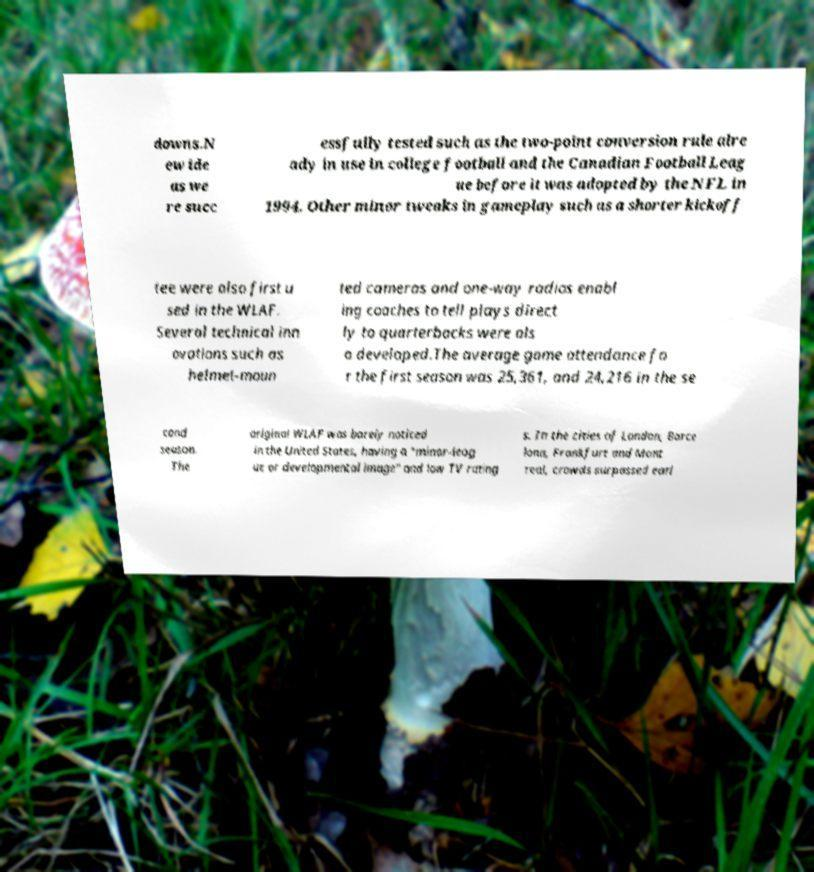For documentation purposes, I need the text within this image transcribed. Could you provide that? downs.N ew ide as we re succ essfully tested such as the two-point conversion rule alre ady in use in college football and the Canadian Football Leag ue before it was adopted by the NFL in 1994. Other minor tweaks in gameplay such as a shorter kickoff tee were also first u sed in the WLAF. Several technical inn ovations such as helmet-moun ted cameras and one-way radios enabl ing coaches to tell plays direct ly to quarterbacks were als o developed.The average game attendance fo r the first season was 25,361, and 24,216 in the se cond season. The original WLAF was barely noticed in the United States, having a "minor-leag ue or developmental image" and low TV rating s. In the cities of London, Barce lona, Frankfurt and Mont real, crowds surpassed earl 